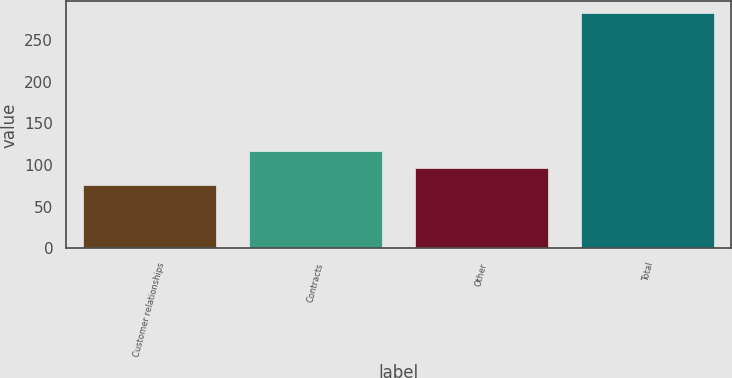Convert chart to OTSL. <chart><loc_0><loc_0><loc_500><loc_500><bar_chart><fcel>Customer relationships<fcel>Contracts<fcel>Other<fcel>Total<nl><fcel>76<fcel>117.2<fcel>96.6<fcel>282<nl></chart> 